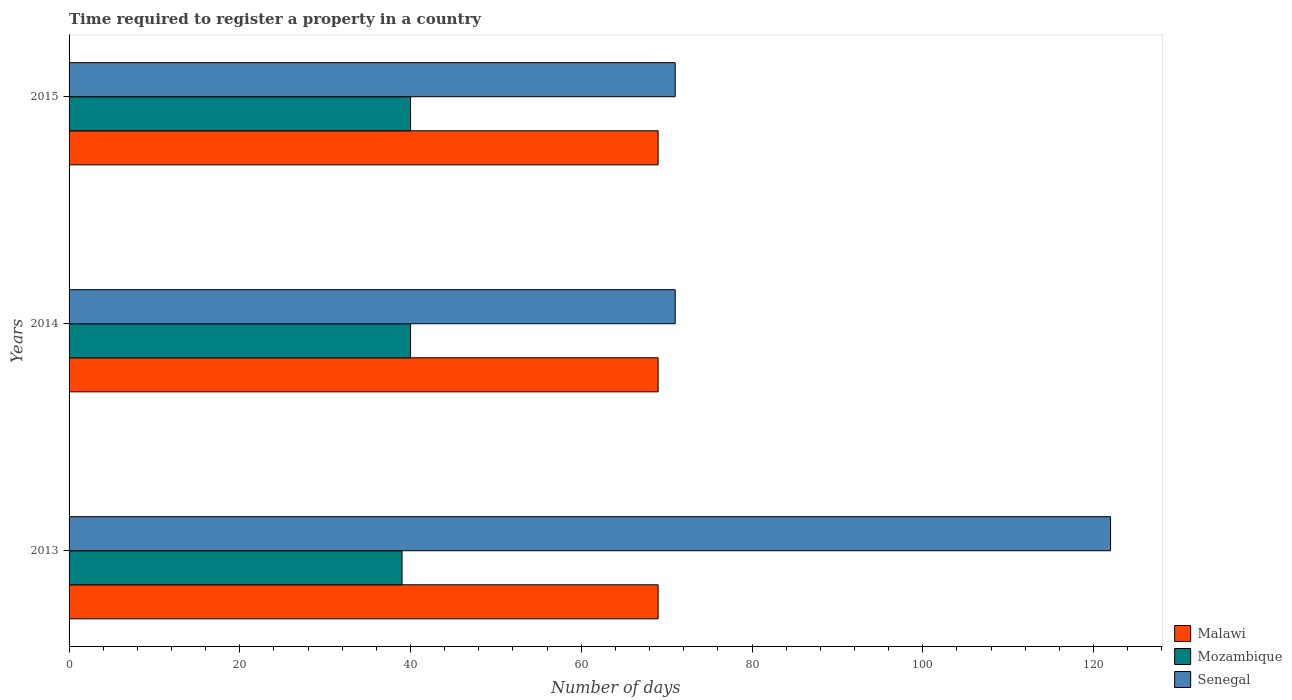How many different coloured bars are there?
Your answer should be compact. 3. Are the number of bars per tick equal to the number of legend labels?
Provide a short and direct response. Yes. Are the number of bars on each tick of the Y-axis equal?
Ensure brevity in your answer.  Yes. How many bars are there on the 2nd tick from the bottom?
Make the answer very short. 3. What is the label of the 1st group of bars from the top?
Your response must be concise. 2015. In how many cases, is the number of bars for a given year not equal to the number of legend labels?
Provide a short and direct response. 0. What is the number of days required to register a property in Mozambique in 2013?
Give a very brief answer. 39. Across all years, what is the maximum number of days required to register a property in Mozambique?
Offer a terse response. 40. Across all years, what is the minimum number of days required to register a property in Malawi?
Make the answer very short. 69. What is the total number of days required to register a property in Senegal in the graph?
Give a very brief answer. 264. What is the difference between the number of days required to register a property in Senegal in 2014 and the number of days required to register a property in Malawi in 2013?
Provide a short and direct response. 2. What is the average number of days required to register a property in Senegal per year?
Make the answer very short. 88. In the year 2015, what is the difference between the number of days required to register a property in Senegal and number of days required to register a property in Malawi?
Keep it short and to the point. 2. Is the difference between the number of days required to register a property in Senegal in 2013 and 2014 greater than the difference between the number of days required to register a property in Malawi in 2013 and 2014?
Offer a very short reply. Yes. What is the difference between the highest and the second highest number of days required to register a property in Malawi?
Provide a succinct answer. 0. What is the difference between the highest and the lowest number of days required to register a property in Mozambique?
Provide a succinct answer. 1. In how many years, is the number of days required to register a property in Mozambique greater than the average number of days required to register a property in Mozambique taken over all years?
Ensure brevity in your answer.  2. What does the 1st bar from the top in 2015 represents?
Your answer should be very brief. Senegal. What does the 2nd bar from the bottom in 2013 represents?
Provide a succinct answer. Mozambique. Is it the case that in every year, the sum of the number of days required to register a property in Mozambique and number of days required to register a property in Malawi is greater than the number of days required to register a property in Senegal?
Ensure brevity in your answer.  No. Are the values on the major ticks of X-axis written in scientific E-notation?
Give a very brief answer. No. Does the graph contain any zero values?
Your response must be concise. No. Where does the legend appear in the graph?
Keep it short and to the point. Bottom right. How many legend labels are there?
Offer a terse response. 3. What is the title of the graph?
Provide a short and direct response. Time required to register a property in a country. What is the label or title of the X-axis?
Ensure brevity in your answer.  Number of days. What is the Number of days in Mozambique in 2013?
Keep it short and to the point. 39. What is the Number of days in Senegal in 2013?
Offer a very short reply. 122. What is the Number of days of Senegal in 2015?
Provide a succinct answer. 71. Across all years, what is the maximum Number of days in Malawi?
Provide a succinct answer. 69. Across all years, what is the maximum Number of days of Mozambique?
Your answer should be very brief. 40. Across all years, what is the maximum Number of days in Senegal?
Offer a very short reply. 122. What is the total Number of days in Malawi in the graph?
Provide a succinct answer. 207. What is the total Number of days of Mozambique in the graph?
Offer a very short reply. 119. What is the total Number of days of Senegal in the graph?
Give a very brief answer. 264. What is the difference between the Number of days in Mozambique in 2013 and that in 2014?
Keep it short and to the point. -1. What is the difference between the Number of days of Senegal in 2013 and that in 2014?
Keep it short and to the point. 51. What is the difference between the Number of days in Mozambique in 2013 and that in 2015?
Your answer should be compact. -1. What is the difference between the Number of days of Senegal in 2014 and that in 2015?
Ensure brevity in your answer.  0. What is the difference between the Number of days of Malawi in 2013 and the Number of days of Mozambique in 2014?
Provide a succinct answer. 29. What is the difference between the Number of days in Mozambique in 2013 and the Number of days in Senegal in 2014?
Offer a very short reply. -32. What is the difference between the Number of days in Mozambique in 2013 and the Number of days in Senegal in 2015?
Ensure brevity in your answer.  -32. What is the difference between the Number of days in Mozambique in 2014 and the Number of days in Senegal in 2015?
Keep it short and to the point. -31. What is the average Number of days of Malawi per year?
Your answer should be compact. 69. What is the average Number of days of Mozambique per year?
Keep it short and to the point. 39.67. In the year 2013, what is the difference between the Number of days of Malawi and Number of days of Senegal?
Ensure brevity in your answer.  -53. In the year 2013, what is the difference between the Number of days in Mozambique and Number of days in Senegal?
Offer a very short reply. -83. In the year 2014, what is the difference between the Number of days in Malawi and Number of days in Senegal?
Provide a short and direct response. -2. In the year 2014, what is the difference between the Number of days of Mozambique and Number of days of Senegal?
Offer a terse response. -31. In the year 2015, what is the difference between the Number of days of Malawi and Number of days of Mozambique?
Give a very brief answer. 29. In the year 2015, what is the difference between the Number of days of Malawi and Number of days of Senegal?
Give a very brief answer. -2. In the year 2015, what is the difference between the Number of days of Mozambique and Number of days of Senegal?
Keep it short and to the point. -31. What is the ratio of the Number of days of Malawi in 2013 to that in 2014?
Give a very brief answer. 1. What is the ratio of the Number of days in Senegal in 2013 to that in 2014?
Your answer should be very brief. 1.72. What is the ratio of the Number of days of Mozambique in 2013 to that in 2015?
Your answer should be very brief. 0.97. What is the ratio of the Number of days of Senegal in 2013 to that in 2015?
Make the answer very short. 1.72. What is the ratio of the Number of days in Malawi in 2014 to that in 2015?
Keep it short and to the point. 1. What is the difference between the highest and the lowest Number of days of Malawi?
Provide a succinct answer. 0. What is the difference between the highest and the lowest Number of days in Senegal?
Your answer should be very brief. 51. 